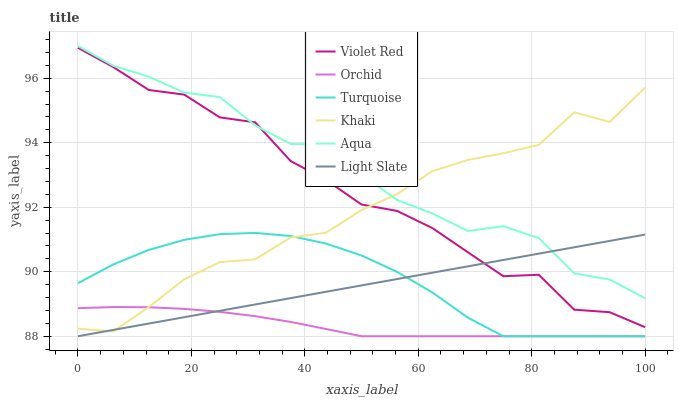Does Orchid have the minimum area under the curve?
Answer yes or no. Yes. Does Aqua have the maximum area under the curve?
Answer yes or no. Yes. Does Khaki have the minimum area under the curve?
Answer yes or no. No. Does Khaki have the maximum area under the curve?
Answer yes or no. No. Is Light Slate the smoothest?
Answer yes or no. Yes. Is Violet Red the roughest?
Answer yes or no. Yes. Is Khaki the smoothest?
Answer yes or no. No. Is Khaki the roughest?
Answer yes or no. No. Does Khaki have the lowest value?
Answer yes or no. No. Does Aqua have the highest value?
Answer yes or no. Yes. Does Khaki have the highest value?
Answer yes or no. No. Is Orchid less than Violet Red?
Answer yes or no. Yes. Is Aqua greater than Turquoise?
Answer yes or no. Yes. Does Khaki intersect Light Slate?
Answer yes or no. Yes. Is Khaki less than Light Slate?
Answer yes or no. No. Is Khaki greater than Light Slate?
Answer yes or no. No. Does Orchid intersect Violet Red?
Answer yes or no. No. 